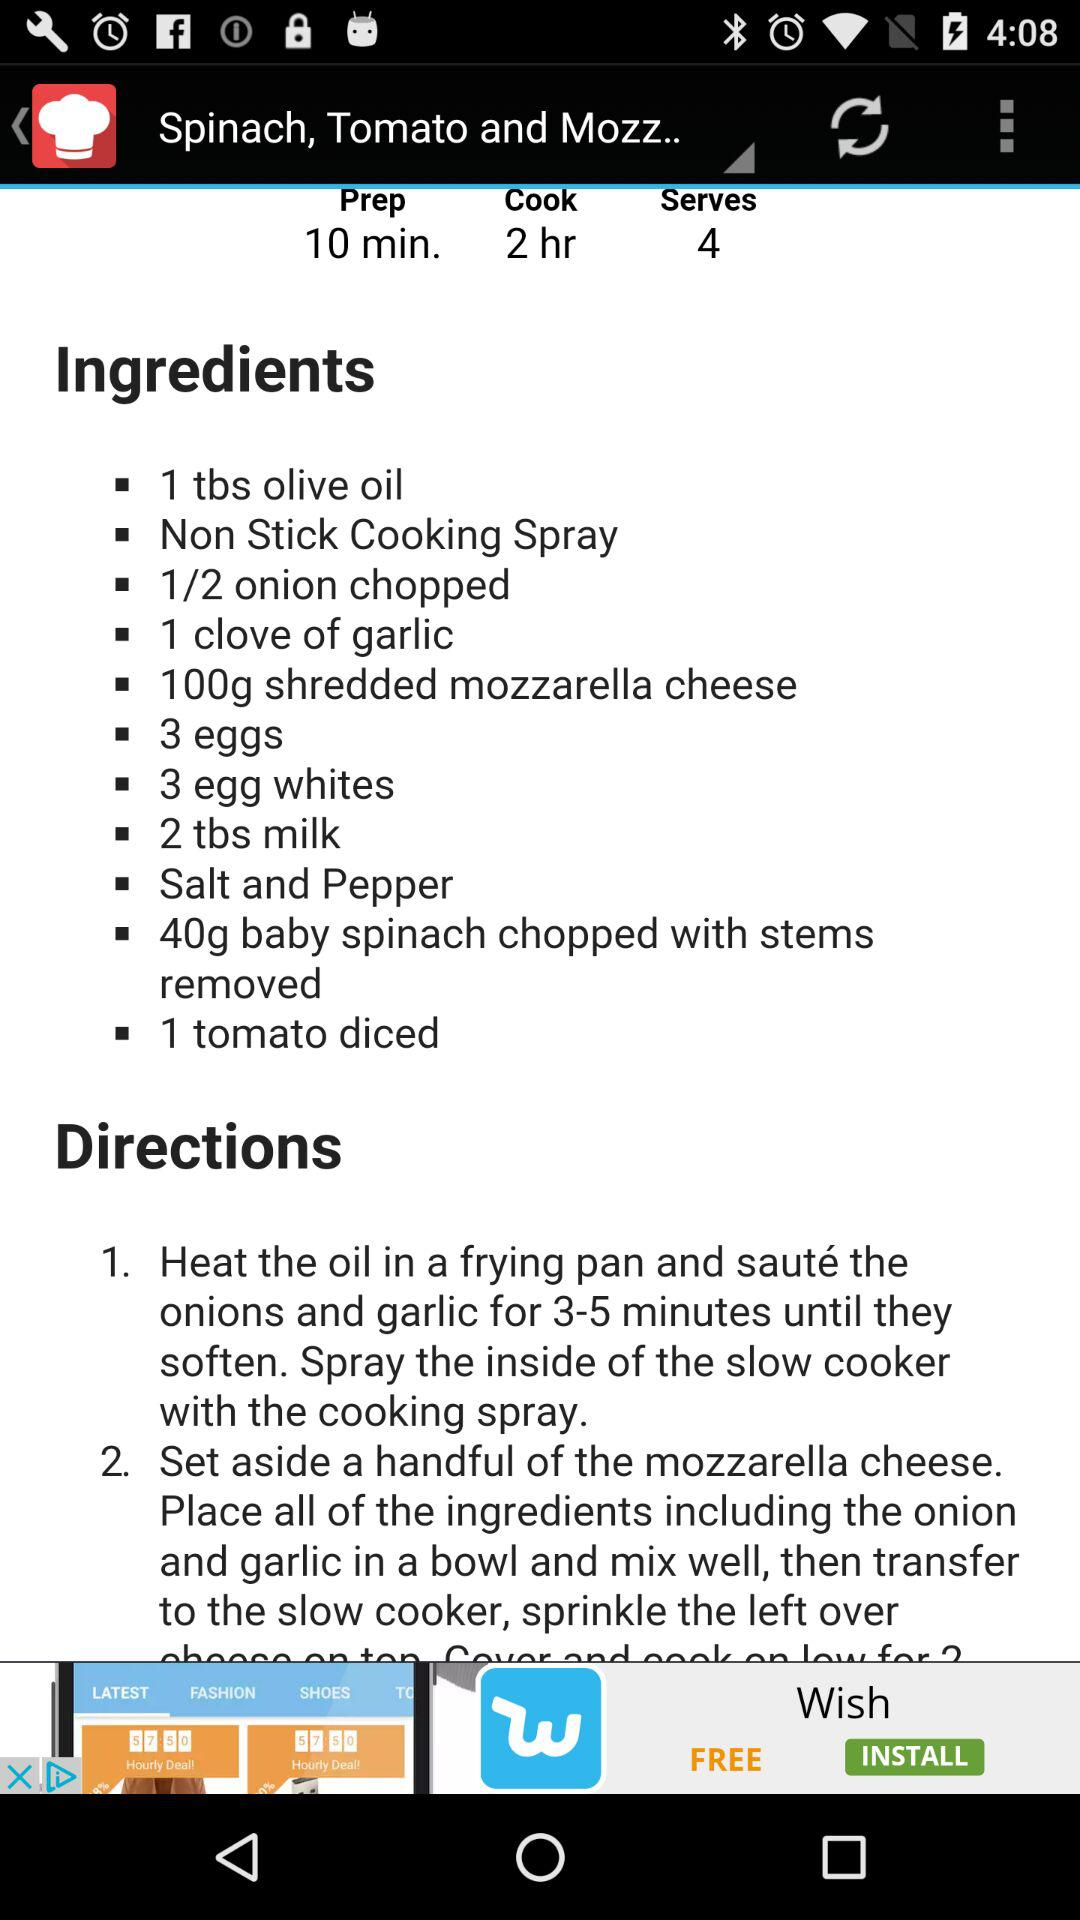How much time will it take to prepare the dish? It will take 10 minutes to prepare the dish. 